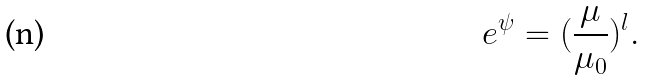<formula> <loc_0><loc_0><loc_500><loc_500>e ^ { \psi } = ( { \frac { \mu } { { \mu _ { 0 } } } } ) ^ { l } .</formula> 